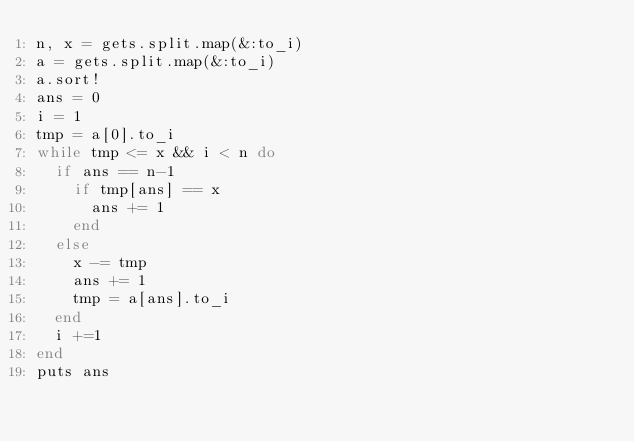<code> <loc_0><loc_0><loc_500><loc_500><_Ruby_>n, x = gets.split.map(&:to_i)
a = gets.split.map(&:to_i)
a.sort!
ans = 0
i = 1
tmp = a[0].to_i
while tmp <= x && i < n do
  if ans == n-1
    if tmp[ans] == x
      ans += 1
    end
  else
    x -= tmp
    ans += 1
    tmp = a[ans].to_i
  end
  i +=1
end
puts ans
</code> 